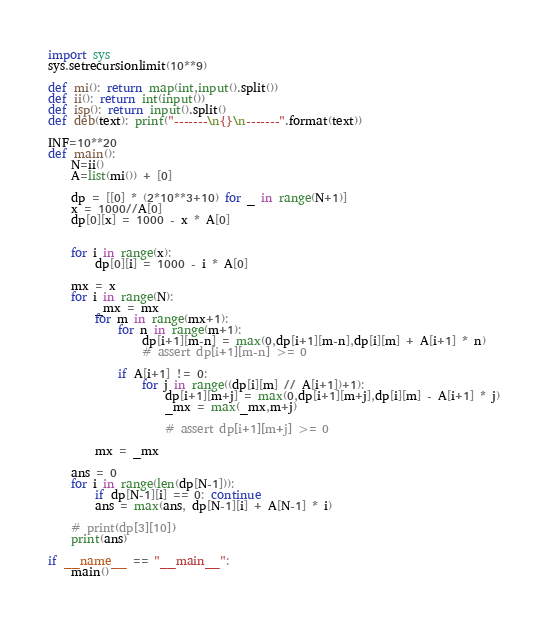<code> <loc_0><loc_0><loc_500><loc_500><_Python_>import sys
sys.setrecursionlimit(10**9)

def mi(): return map(int,input().split())
def ii(): return int(input())
def isp(): return input().split()
def deb(text): print("-------\n{}\n-------".format(text))

INF=10**20
def main():
    N=ii()
    A=list(mi()) + [0]

    dp = [[0] * (2*10**3+10) for _ in range(N+1)]
    x = 1000//A[0]
    dp[0][x] = 1000 - x * A[0]


    for i in range(x):
        dp[0][i] = 1000 - i * A[0]

    mx = x
    for i in range(N):
        _mx = mx
        for m in range(mx+1):
            for n in range(m+1):
                dp[i+1][m-n] = max(0,dp[i+1][m-n],dp[i][m] + A[i+1] * n)
                # assert dp[i+1][m-n] >= 0
            
            if A[i+1] != 0:
                for j in range((dp[i][m] // A[i+1])+1):
                    dp[i+1][m+j] = max(0,dp[i+1][m+j],dp[i][m] - A[i+1] * j)
                    _mx = max(_mx,m+j)
                    
                    # assert dp[i+1][m+j] >= 0

        mx = _mx

    ans = 0
    for i in range(len(dp[N-1])):
        if dp[N-1][i] == 0: continue
        ans = max(ans, dp[N-1][i] + A[N-1] * i)

    # print(dp[3][10])
    print(ans)

if __name__ == "__main__":
    main()</code> 